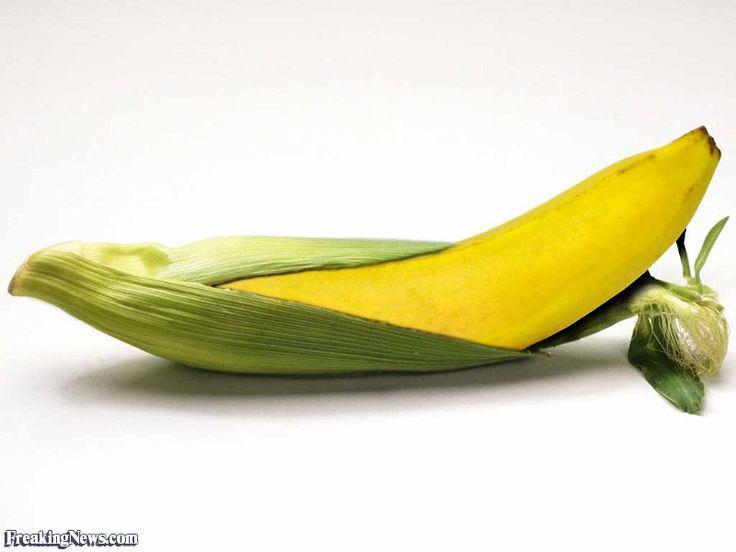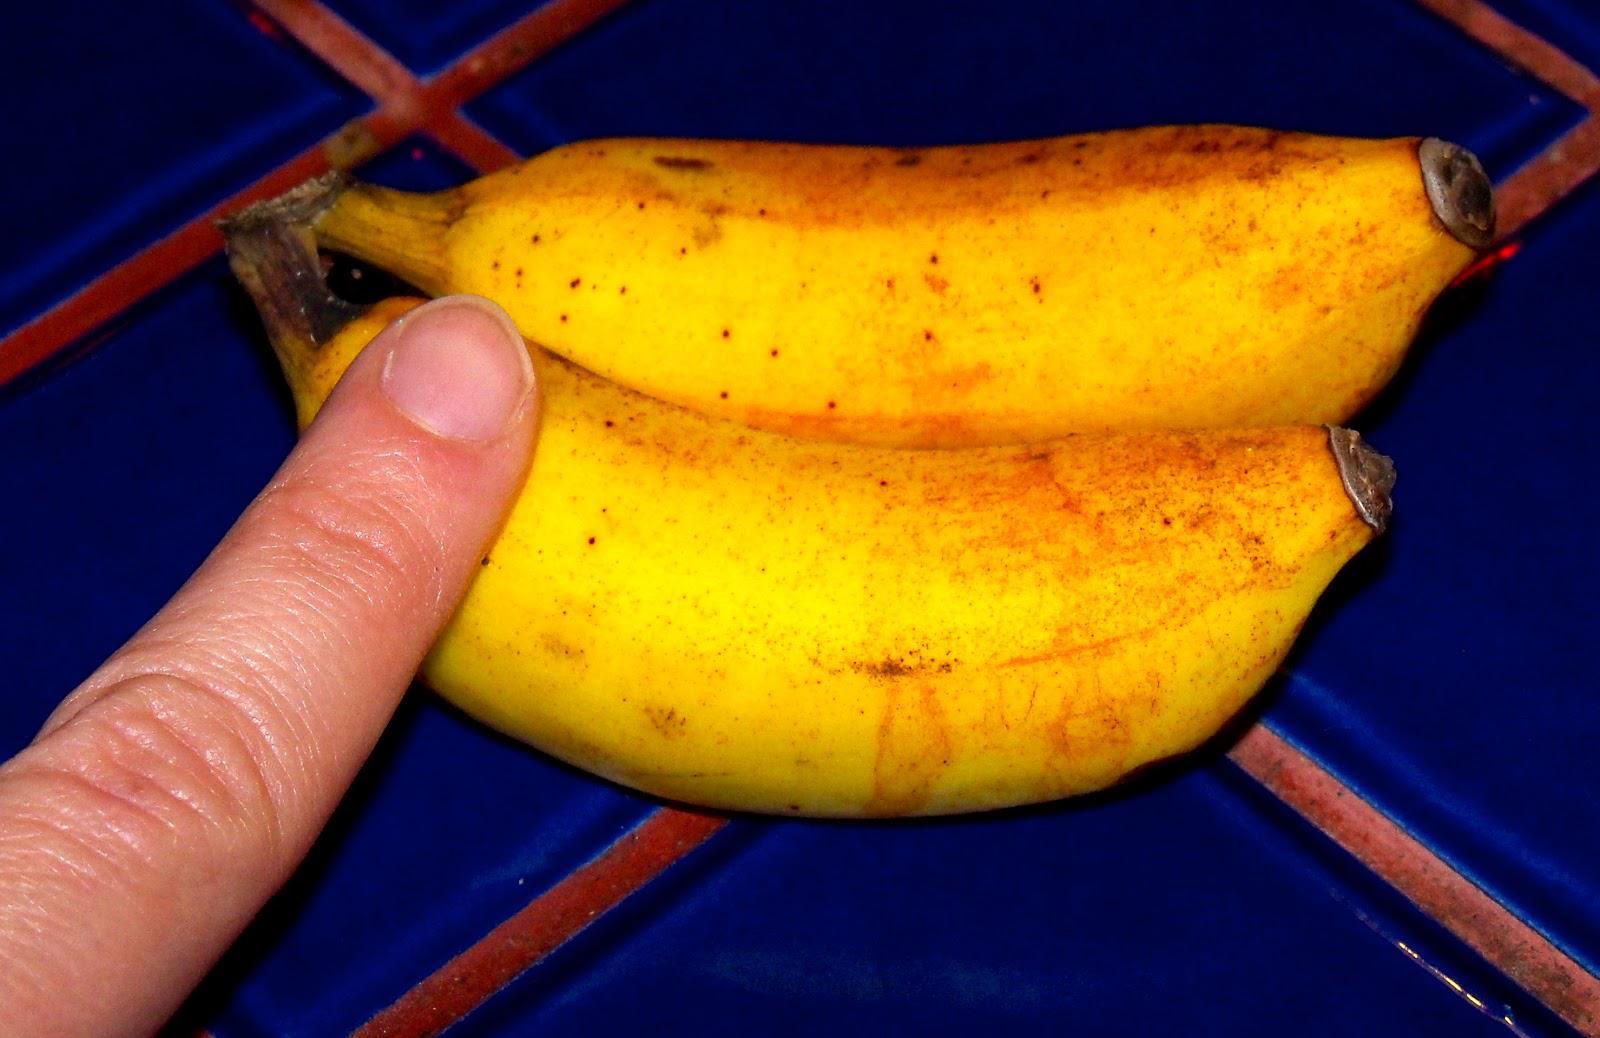The first image is the image on the left, the second image is the image on the right. Assess this claim about the two images: "One of the images features a vegetable turning in to a banana.". Correct or not? Answer yes or no. Yes. The first image is the image on the left, the second image is the image on the right. Examine the images to the left and right. Is the description "There are real bananas in one of the images." accurate? Answer yes or no. Yes. 